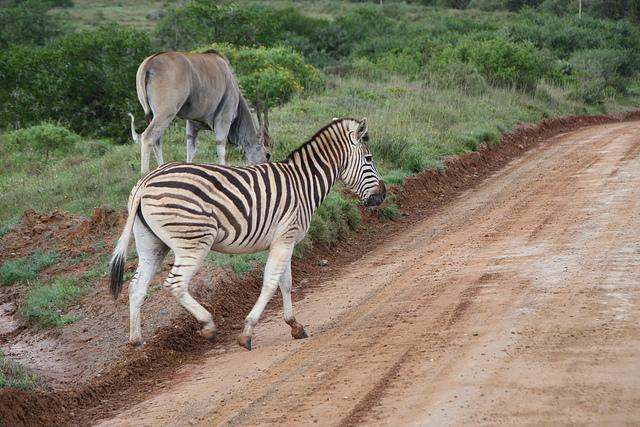What is the zebra on the left about to step into? road 